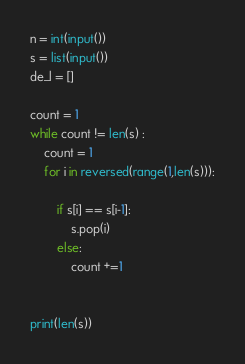<code> <loc_0><loc_0><loc_500><loc_500><_Python_>n = int(input())
s = list(input())
de_l = []

count = 1
while count != len(s) :
	count = 1
	for i in reversed(range(1,len(s))):
		
		if s[i] == s[i-1]:
			s.pop(i)
		else:
			count +=1


print(len(s))
</code> 